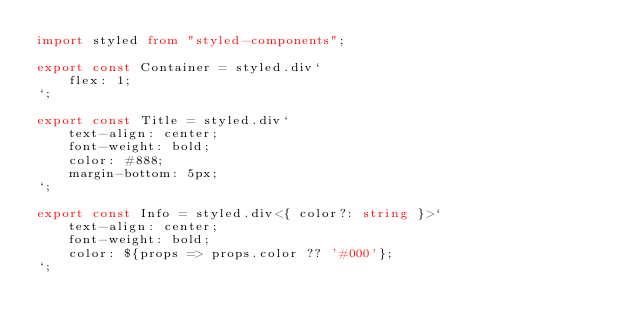Convert code to text. <code><loc_0><loc_0><loc_500><loc_500><_TypeScript_>import styled from "styled-components";

export const Container = styled.div`
    flex: 1;
`;

export const Title = styled.div`
    text-align: center;
    font-weight: bold;
    color: #888;
    margin-bottom: 5px;
`;

export const Info = styled.div<{ color?: string }>`
    text-align: center;
    font-weight: bold;
    color: ${props => props.color ?? '#000'};
`;</code> 